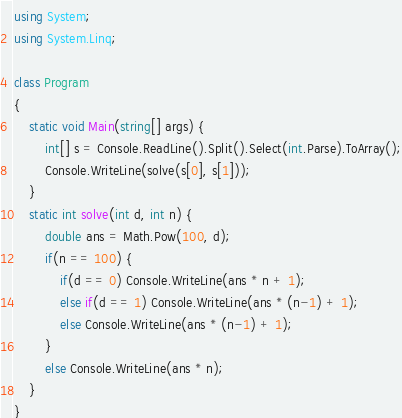<code> <loc_0><loc_0><loc_500><loc_500><_C#_>using System;
using System.Linq;
 
class Program
{
    static void Main(string[] args) {
        int[] s = Console.ReadLine().Split().Select(int.Parse).ToArray();
        Console.WriteLine(solve(s[0], s[1]));
    }
    static int solve(int d, int n) {
        double ans = Math.Pow(100, d);
        if(n == 100) {
            if(d == 0) Console.WriteLine(ans * n + 1);
            else if(d == 1) Console.WriteLine(ans * (n-1) + 1);
            else Console.WriteLine(ans * (n-1) + 1);
        }
        else Console.WriteLine(ans * n);
    }
}</code> 